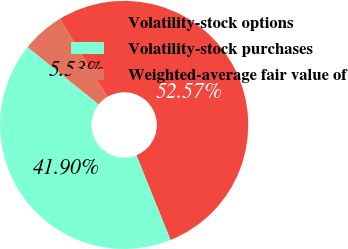Convert chart to OTSL. <chart><loc_0><loc_0><loc_500><loc_500><pie_chart><fcel>Volatility-stock options<fcel>Volatility-stock purchases<fcel>Weighted-average fair value of<nl><fcel>52.58%<fcel>41.9%<fcel>5.53%<nl></chart> 